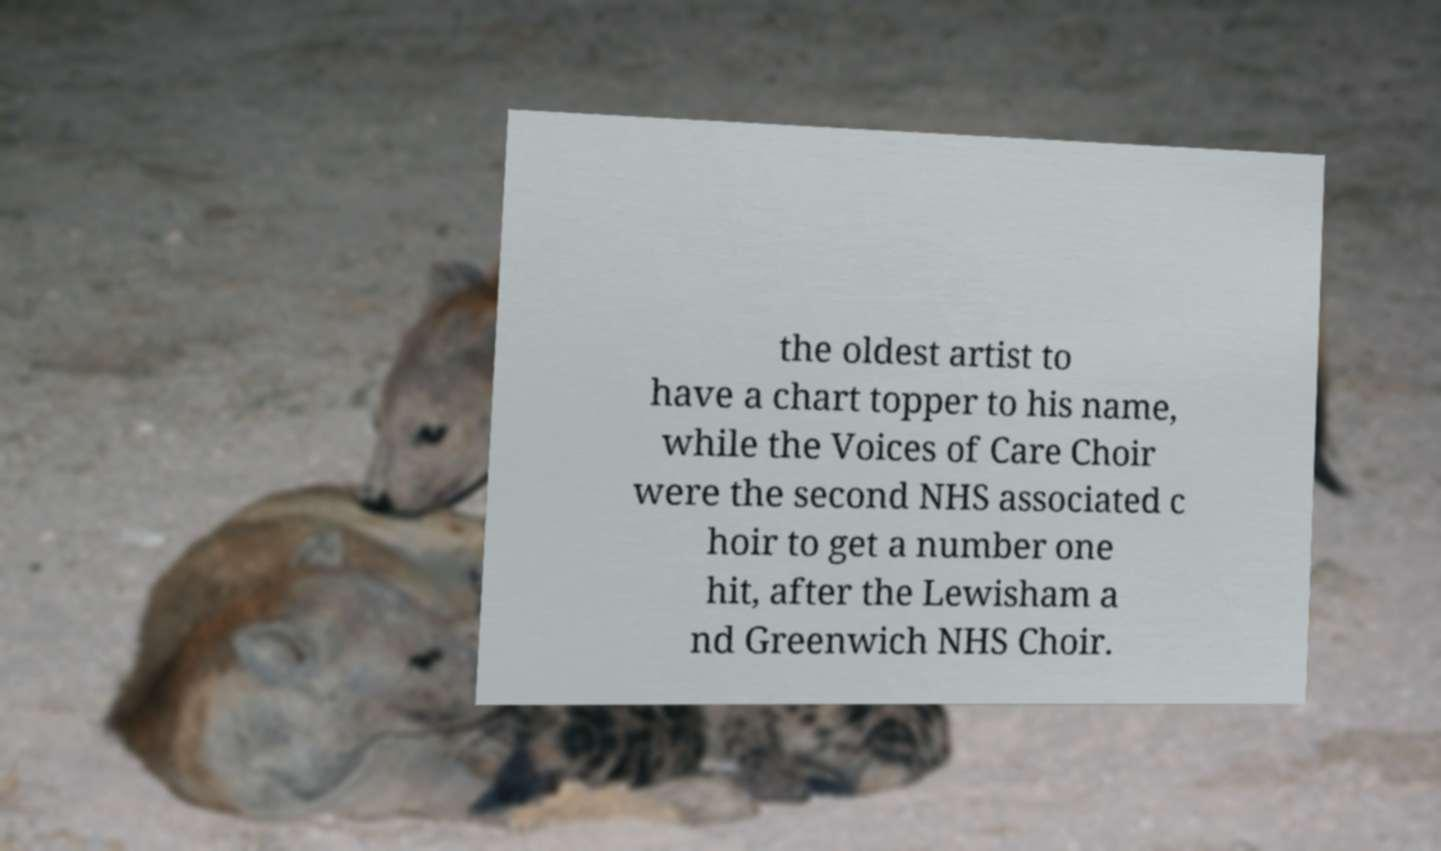Can you read and provide the text displayed in the image?This photo seems to have some interesting text. Can you extract and type it out for me? the oldest artist to have a chart topper to his name, while the Voices of Care Choir were the second NHS associated c hoir to get a number one hit, after the Lewisham a nd Greenwich NHS Choir. 